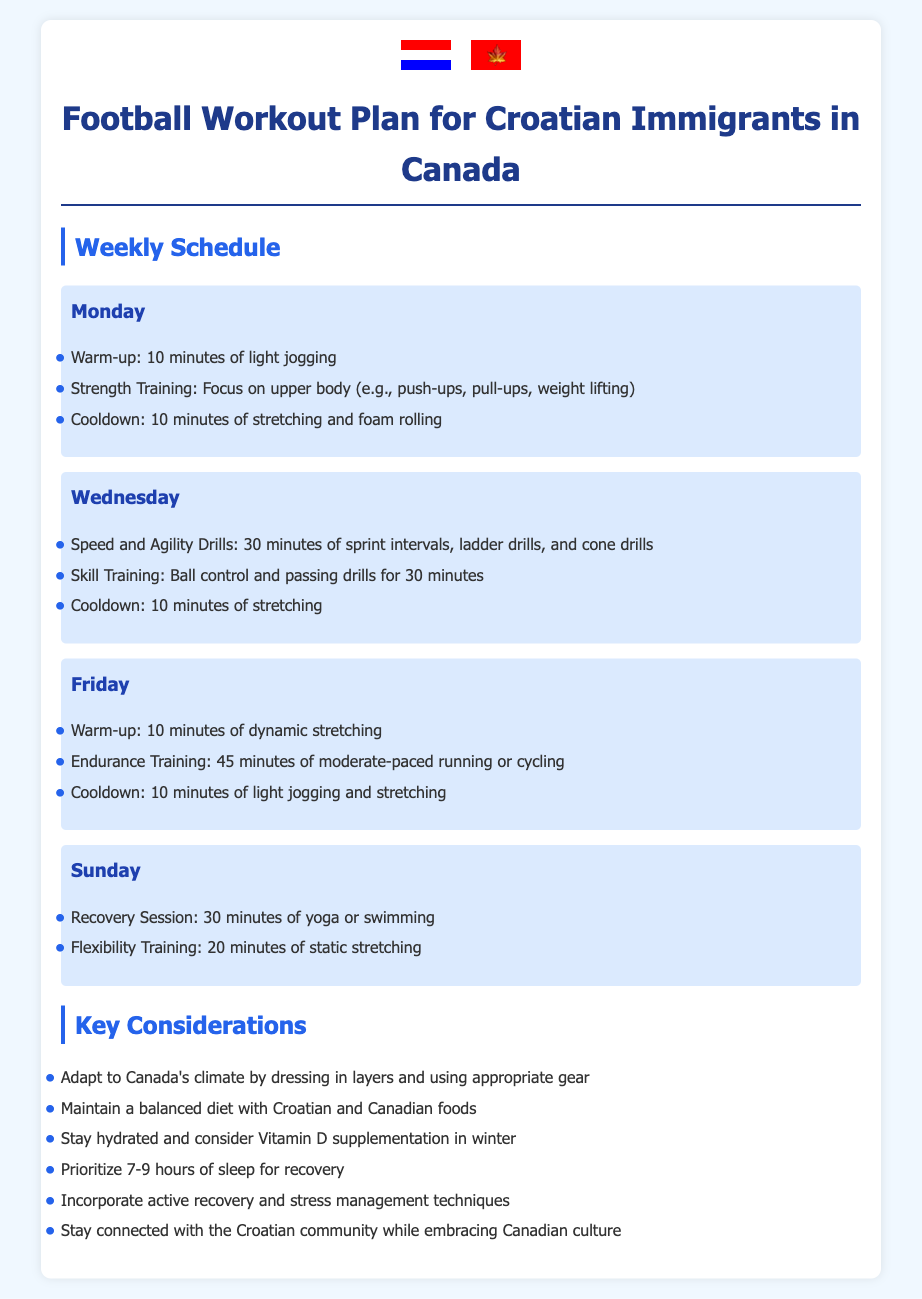What day is dedicated to recovery sessions? The document specifies that recovery sessions are scheduled for Sunday.
Answer: Sunday How long is the endurance training session? The endurance training session on Friday is stated to last for 45 minutes.
Answer: 45 minutes What type of training is scheduled for Wednesday? The Wednesday training includes speed and agility drills followed by skill training.
Answer: Speed and Agility Drills How many hours of sleep are prioritized for recovery? The guidelines recommend prioritizing 7-9 hours of sleep for recovery.
Answer: 7-9 hours Which two types of training are alternated throughout the week? The document alternates between strength training and endurance training.
Answer: Strength and Endurance Training What should be considered for hydration during winter months? It suggests considering Vitamin D supplementation in winter for hydration.
Answer: Vitamin D supplementation What is one key adaptation suggested for Canada's climate? Dressing in layers and using appropriate gear is suggested as an adaptation.
Answer: Dressing in layers What is included in the cooldown for strength training? The cooldown for strength training includes 10 minutes of stretching and foam rolling.
Answer: Stretching and foam rolling 